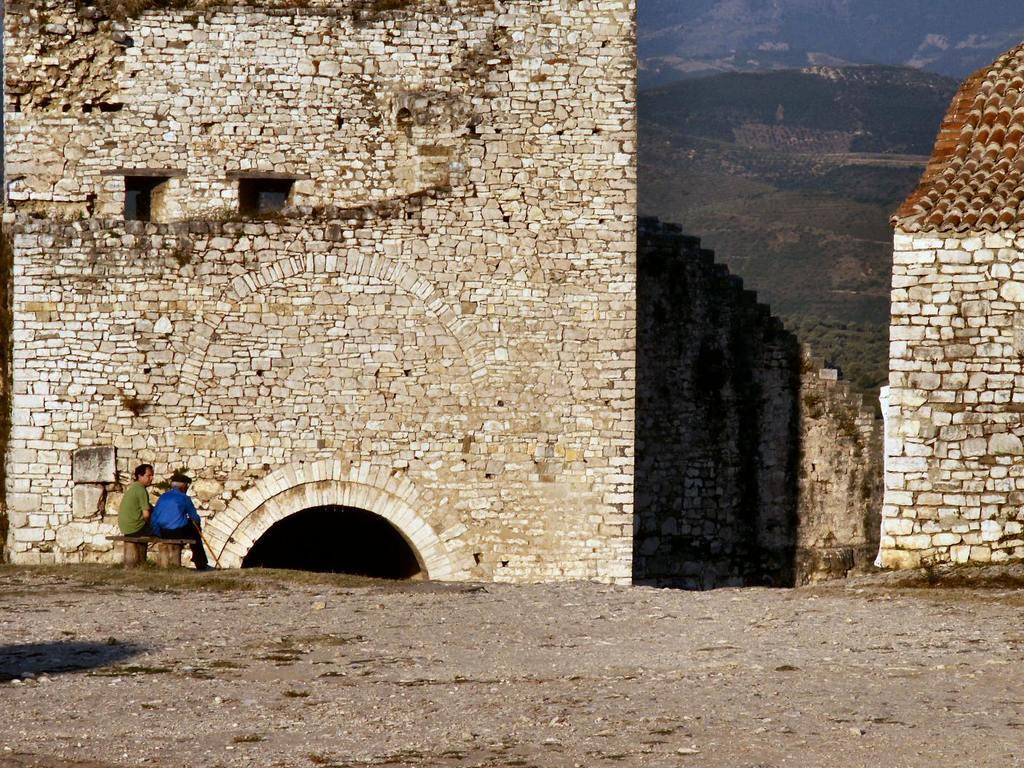What can be seen on the left side of the image? There are persons sitting on a bench on the left side of the image. What is visible at the bottom of the image? The ground is visible at the bottom of the image. What can be seen in the background of the image? There are buildings, hills, and trees in the background of the image. How many pies are being held by the women in the image? There are no women or pies present in the image. What type of line can be seen connecting the hills in the image? There is no line connecting the hills in the image; the hills are separate features in the background. 